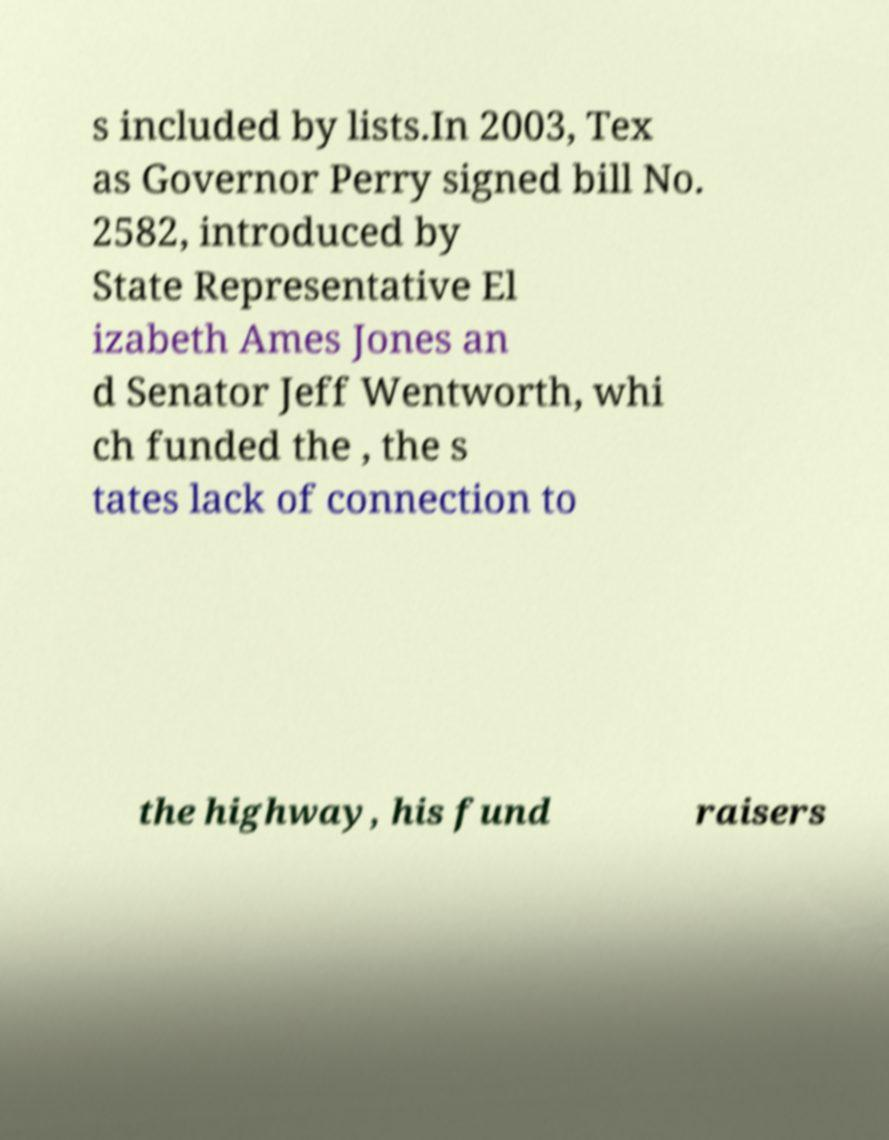Could you extract and type out the text from this image? s included by lists.In 2003, Tex as Governor Perry signed bill No. 2582, introduced by State Representative El izabeth Ames Jones an d Senator Jeff Wentworth, whi ch funded the , the s tates lack of connection to the highway, his fund raisers 